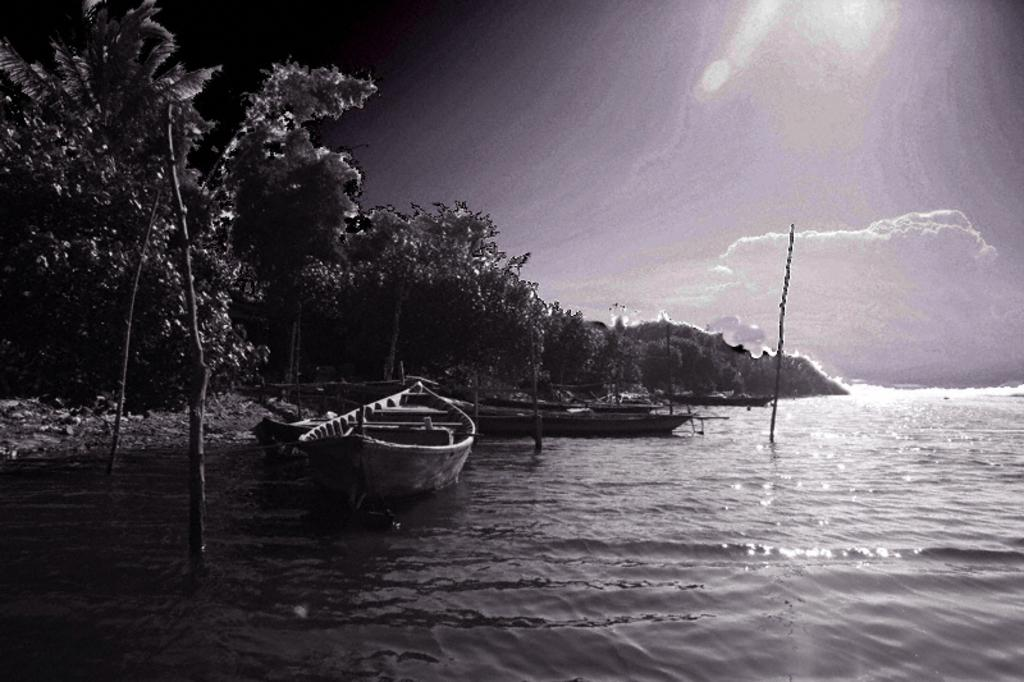What type of vehicles can be seen on the water in the image? There are boats on the water in the image. What type of vegetation is visible in the image? There are trees in the left corner of the image. What type of record can be seen being played by the birds in the image? There are no birds or records present in the image. What is the head count of the people in the image? There is no reference to people or a head count in the image. 